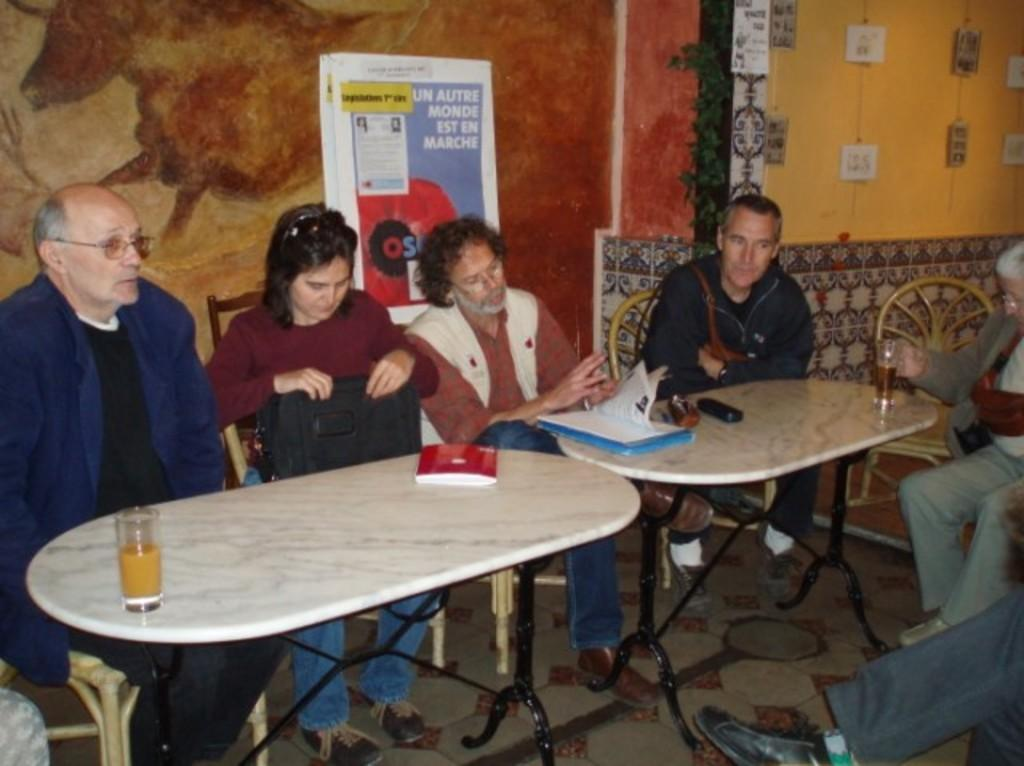How many people are in the image? There is a group of people in the image. What are the people doing in the image? The people are sitting in chairs. What is in front of the people? There is a table in front of the people. What items can be found on the table? The table contains books, papers, and a glass. What type of cap is the snow wearing in the image? There is no cap or snow present in the image. What mathematical operation is being performed by the people in the image? The provided facts do not mention any mathematical operations or calculations being performed by the people in the image. 